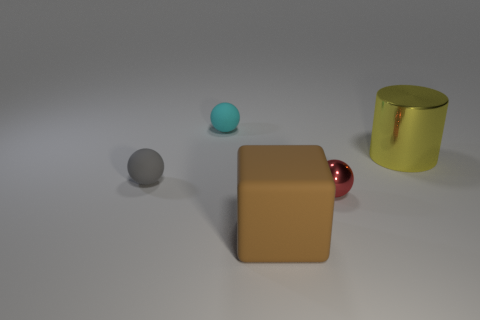Do the tiny ball that is on the right side of the brown matte block and the shiny thing that is behind the tiny metallic sphere have the same color?
Offer a very short reply. No. The tiny object that is to the right of the small rubber object that is behind the cylinder in front of the cyan thing is what shape?
Offer a terse response. Sphere. What shape is the matte thing that is behind the big brown block and in front of the cyan rubber object?
Provide a succinct answer. Sphere. How many gray matte objects are behind the small matte thing behind the yellow cylinder to the right of the large brown rubber block?
Offer a very short reply. 0. There is a red object that is the same shape as the gray object; what is its size?
Your answer should be compact. Small. Is there any other thing that is the same size as the gray sphere?
Provide a succinct answer. Yes. Is the large object to the left of the large metal object made of the same material as the red ball?
Ensure brevity in your answer.  No. There is a tiny metal thing that is the same shape as the tiny cyan rubber object; what color is it?
Ensure brevity in your answer.  Red. How many other things are there of the same color as the shiny sphere?
Offer a very short reply. 0. There is a tiny thing that is to the right of the rubber cube; is its shape the same as the large thing on the right side of the large brown rubber object?
Give a very brief answer. No. 